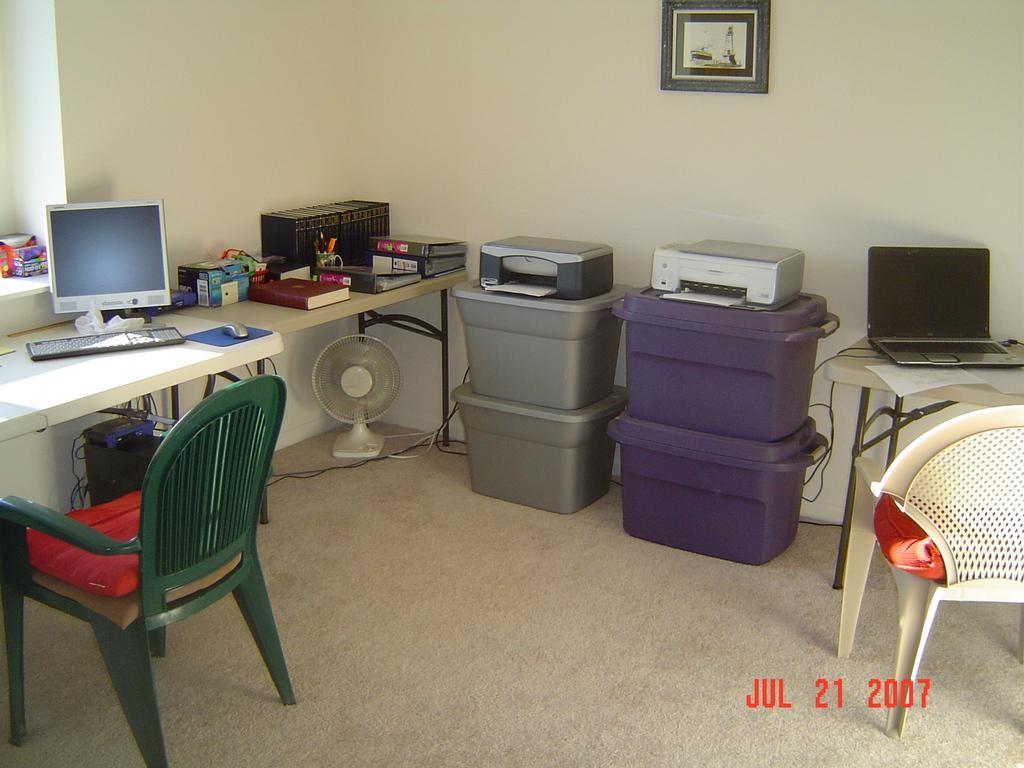Please provide a concise description of this image. On the left side of the image there is a chair with pillows. In front of the chair, there is a table with monitor, keyboard, mouse and there are few books. Below the table there is a table fan, CPU and wires. Beside the table there are boxes with printers. On the right corner of the image there is a table with a laptop and also there are wires. In the background there is a wall with a frame.  